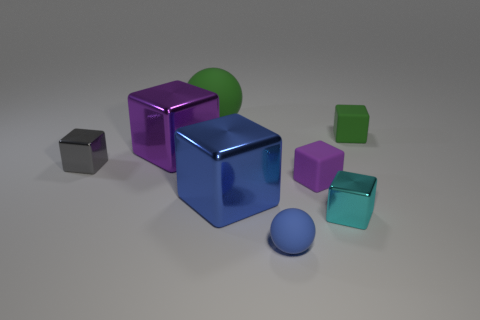Subtract 1 cubes. How many cubes are left? 5 Subtract all green cubes. How many cubes are left? 5 Subtract all purple metallic cubes. How many cubes are left? 5 Subtract all gray spheres. Subtract all brown cylinders. How many spheres are left? 2 Add 1 purple blocks. How many objects exist? 9 Subtract all balls. How many objects are left? 6 Add 5 large green things. How many large green things exist? 6 Subtract 0 purple spheres. How many objects are left? 8 Subtract all tiny cyan metal spheres. Subtract all small blue objects. How many objects are left? 7 Add 4 small green blocks. How many small green blocks are left? 5 